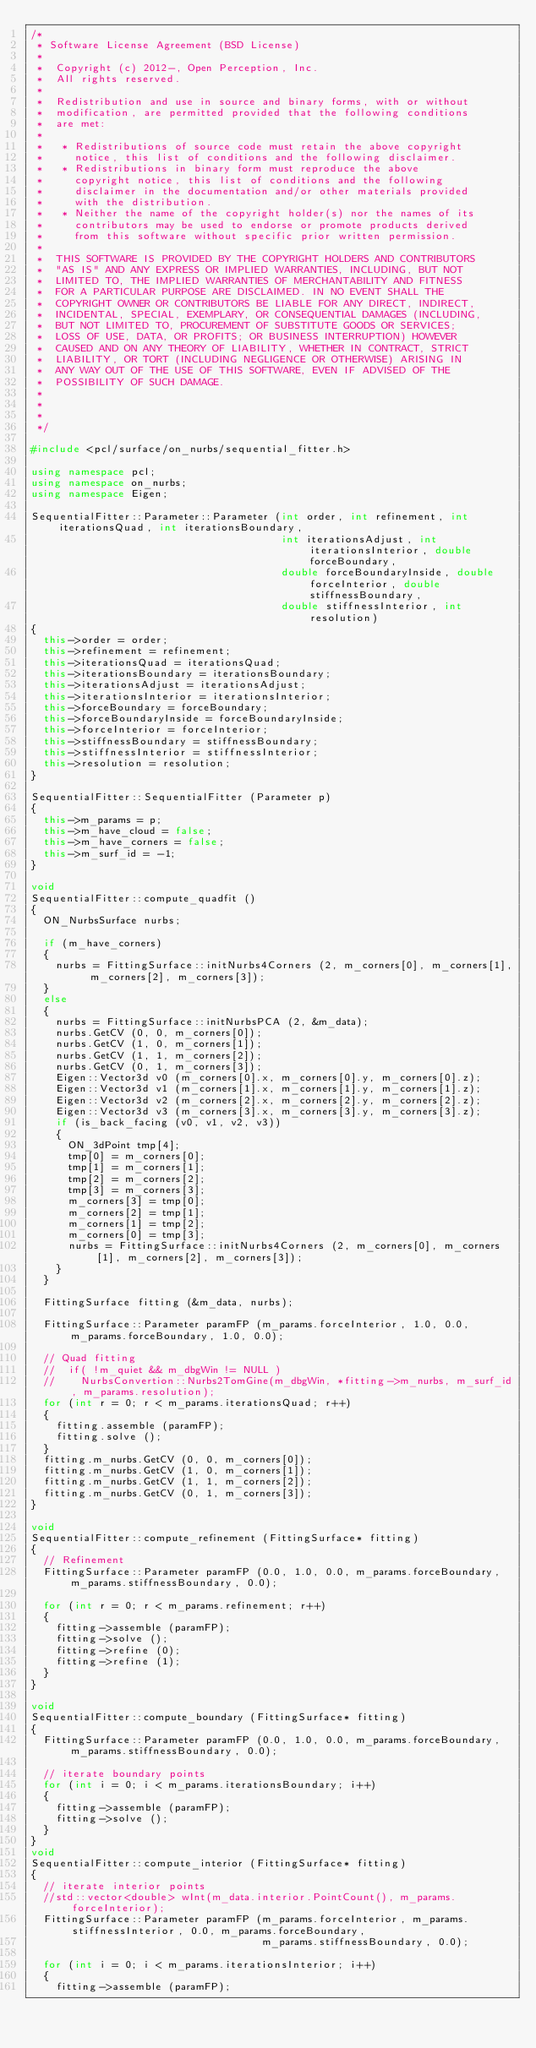<code> <loc_0><loc_0><loc_500><loc_500><_C++_>/*
 * Software License Agreement (BSD License)
 *
 *  Copyright (c) 2012-, Open Perception, Inc.
 *  All rights reserved.
 *
 *  Redistribution and use in source and binary forms, with or without
 *  modification, are permitted provided that the following conditions
 *  are met:
 *
 *   * Redistributions of source code must retain the above copyright
 *     notice, this list of conditions and the following disclaimer.
 *   * Redistributions in binary form must reproduce the above
 *     copyright notice, this list of conditions and the following
 *     disclaimer in the documentation and/or other materials provided
 *     with the distribution.
 *   * Neither the name of the copyright holder(s) nor the names of its
 *     contributors may be used to endorse or promote products derived
 *     from this software without specific prior written permission.
 *
 *  THIS SOFTWARE IS PROVIDED BY THE COPYRIGHT HOLDERS AND CONTRIBUTORS
 *  "AS IS" AND ANY EXPRESS OR IMPLIED WARRANTIES, INCLUDING, BUT NOT
 *  LIMITED TO, THE IMPLIED WARRANTIES OF MERCHANTABILITY AND FITNESS
 *  FOR A PARTICULAR PURPOSE ARE DISCLAIMED. IN NO EVENT SHALL THE
 *  COPYRIGHT OWNER OR CONTRIBUTORS BE LIABLE FOR ANY DIRECT, INDIRECT,
 *  INCIDENTAL, SPECIAL, EXEMPLARY, OR CONSEQUENTIAL DAMAGES (INCLUDING,
 *  BUT NOT LIMITED TO, PROCUREMENT OF SUBSTITUTE GOODS OR SERVICES;
 *  LOSS OF USE, DATA, OR PROFITS; OR BUSINESS INTERRUPTION) HOWEVER
 *  CAUSED AND ON ANY THEORY OF LIABILITY, WHETHER IN CONTRACT, STRICT
 *  LIABILITY, OR TORT (INCLUDING NEGLIGENCE OR OTHERWISE) ARISING IN
 *  ANY WAY OUT OF THE USE OF THIS SOFTWARE, EVEN IF ADVISED OF THE
 *  POSSIBILITY OF SUCH DAMAGE.
 *
 * 
 *
 */

#include <pcl/surface/on_nurbs/sequential_fitter.h>

using namespace pcl;
using namespace on_nurbs;
using namespace Eigen;

SequentialFitter::Parameter::Parameter (int order, int refinement, int iterationsQuad, int iterationsBoundary,
                                        int iterationsAdjust, int iterationsInterior, double forceBoundary,
                                        double forceBoundaryInside, double forceInterior, double stiffnessBoundary,
                                        double stiffnessInterior, int resolution)
{
  this->order = order;
  this->refinement = refinement;
  this->iterationsQuad = iterationsQuad;
  this->iterationsBoundary = iterationsBoundary;
  this->iterationsAdjust = iterationsAdjust;
  this->iterationsInterior = iterationsInterior;
  this->forceBoundary = forceBoundary;
  this->forceBoundaryInside = forceBoundaryInside;
  this->forceInterior = forceInterior;
  this->stiffnessBoundary = stiffnessBoundary;
  this->stiffnessInterior = stiffnessInterior;
  this->resolution = resolution;
}

SequentialFitter::SequentialFitter (Parameter p)
{
  this->m_params = p;
  this->m_have_cloud = false;
  this->m_have_corners = false;
  this->m_surf_id = -1;
}

void
SequentialFitter::compute_quadfit ()
{
  ON_NurbsSurface nurbs;

  if (m_have_corners)
  {
    nurbs = FittingSurface::initNurbs4Corners (2, m_corners[0], m_corners[1], m_corners[2], m_corners[3]);
  }
  else
  {
    nurbs = FittingSurface::initNurbsPCA (2, &m_data);
    nurbs.GetCV (0, 0, m_corners[0]);
    nurbs.GetCV (1, 0, m_corners[1]);
    nurbs.GetCV (1, 1, m_corners[2]);
    nurbs.GetCV (0, 1, m_corners[3]);
    Eigen::Vector3d v0 (m_corners[0].x, m_corners[0].y, m_corners[0].z);
    Eigen::Vector3d v1 (m_corners[1].x, m_corners[1].y, m_corners[1].z);
    Eigen::Vector3d v2 (m_corners[2].x, m_corners[2].y, m_corners[2].z);
    Eigen::Vector3d v3 (m_corners[3].x, m_corners[3].y, m_corners[3].z);
    if (is_back_facing (v0, v1, v2, v3))
    {
      ON_3dPoint tmp[4];
      tmp[0] = m_corners[0];
      tmp[1] = m_corners[1];
      tmp[2] = m_corners[2];
      tmp[3] = m_corners[3];
      m_corners[3] = tmp[0];
      m_corners[2] = tmp[1];
      m_corners[1] = tmp[2];
      m_corners[0] = tmp[3];
      nurbs = FittingSurface::initNurbs4Corners (2, m_corners[0], m_corners[1], m_corners[2], m_corners[3]);
    }
  }

  FittingSurface fitting (&m_data, nurbs);

  FittingSurface::Parameter paramFP (m_params.forceInterior, 1.0, 0.0, m_params.forceBoundary, 1.0, 0.0);

  // Quad fitting
  //  if( !m_quiet && m_dbgWin != NULL )
  //    NurbsConvertion::Nurbs2TomGine(m_dbgWin, *fitting->m_nurbs, m_surf_id, m_params.resolution);
  for (int r = 0; r < m_params.iterationsQuad; r++)
  {
    fitting.assemble (paramFP);
    fitting.solve ();
  }
  fitting.m_nurbs.GetCV (0, 0, m_corners[0]);
  fitting.m_nurbs.GetCV (1, 0, m_corners[1]);
  fitting.m_nurbs.GetCV (1, 1, m_corners[2]);
  fitting.m_nurbs.GetCV (0, 1, m_corners[3]);
}

void
SequentialFitter::compute_refinement (FittingSurface* fitting)
{
  // Refinement
  FittingSurface::Parameter paramFP (0.0, 1.0, 0.0, m_params.forceBoundary, m_params.stiffnessBoundary, 0.0);

  for (int r = 0; r < m_params.refinement; r++)
  {
    fitting->assemble (paramFP);
    fitting->solve ();
    fitting->refine (0);
    fitting->refine (1);
  }
}

void
SequentialFitter::compute_boundary (FittingSurface* fitting)
{
  FittingSurface::Parameter paramFP (0.0, 1.0, 0.0, m_params.forceBoundary, m_params.stiffnessBoundary, 0.0);

  // iterate boundary points
  for (int i = 0; i < m_params.iterationsBoundary; i++)
  {
    fitting->assemble (paramFP);
    fitting->solve ();
  }
}
void
SequentialFitter::compute_interior (FittingSurface* fitting)
{
  // iterate interior points
  //std::vector<double> wInt(m_data.interior.PointCount(), m_params.forceInterior);
  FittingSurface::Parameter paramFP (m_params.forceInterior, m_params.stiffnessInterior, 0.0, m_params.forceBoundary,
                                     m_params.stiffnessBoundary, 0.0);

  for (int i = 0; i < m_params.iterationsInterior; i++)
  {
    fitting->assemble (paramFP);</code> 